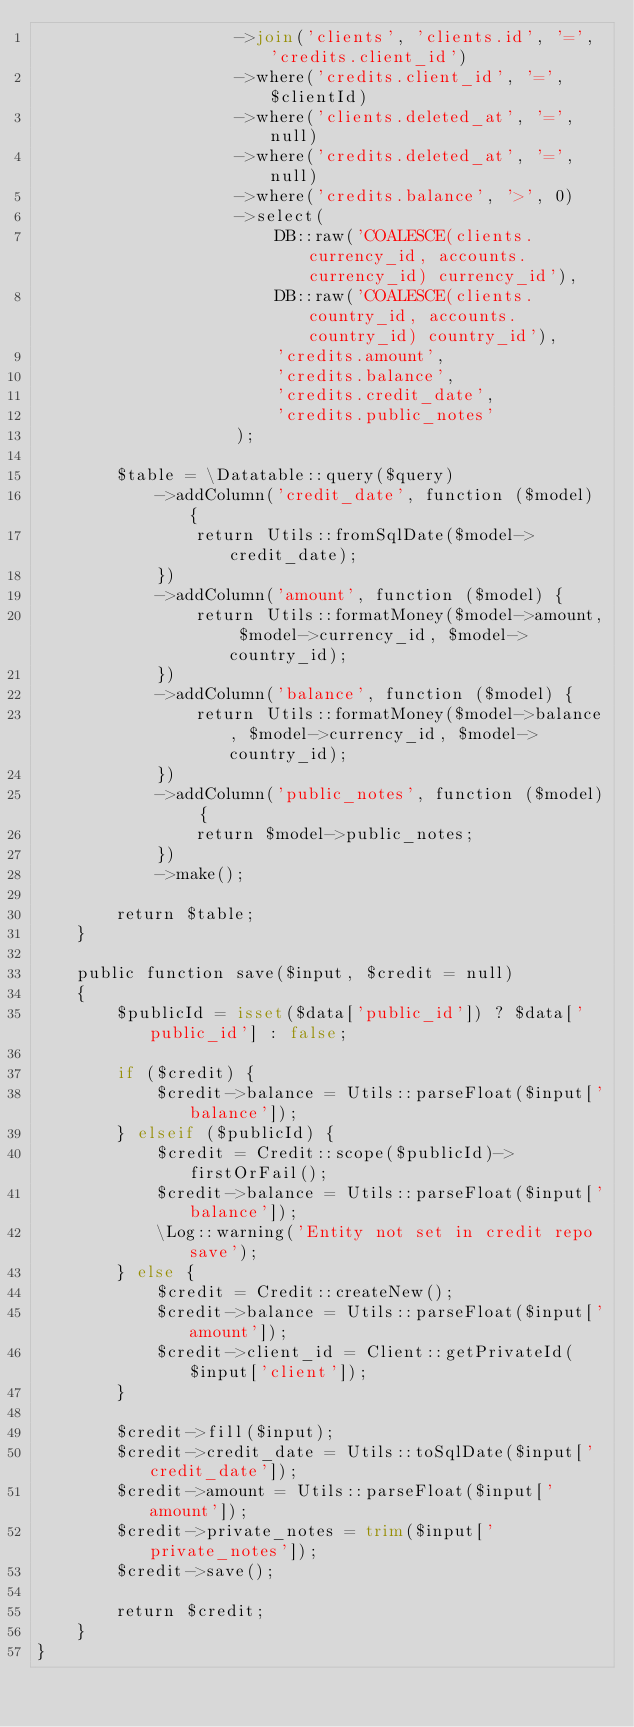Convert code to text. <code><loc_0><loc_0><loc_500><loc_500><_PHP_>                    ->join('clients', 'clients.id', '=', 'credits.client_id')
                    ->where('credits.client_id', '=', $clientId)
                    ->where('clients.deleted_at', '=', null)
                    ->where('credits.deleted_at', '=', null)
                    ->where('credits.balance', '>', 0)
                    ->select(
                        DB::raw('COALESCE(clients.currency_id, accounts.currency_id) currency_id'),
                        DB::raw('COALESCE(clients.country_id, accounts.country_id) country_id'),
                        'credits.amount',
                        'credits.balance',
                        'credits.credit_date',
                        'credits.public_notes'
                    );

        $table = \Datatable::query($query)
            ->addColumn('credit_date', function ($model) {
                return Utils::fromSqlDate($model->credit_date);
            })
            ->addColumn('amount', function ($model) {
                return Utils::formatMoney($model->amount, $model->currency_id, $model->country_id);
            })
            ->addColumn('balance', function ($model) {
                return Utils::formatMoney($model->balance, $model->currency_id, $model->country_id);
            })
            ->addColumn('public_notes', function ($model) {
                return $model->public_notes;
            })
            ->make();

        return $table;
    }

    public function save($input, $credit = null)
    {
        $publicId = isset($data['public_id']) ? $data['public_id'] : false;

        if ($credit) {
            $credit->balance = Utils::parseFloat($input['balance']);
        } elseif ($publicId) {
            $credit = Credit::scope($publicId)->firstOrFail();
            $credit->balance = Utils::parseFloat($input['balance']);
            \Log::warning('Entity not set in credit repo save');
        } else {
            $credit = Credit::createNew();
            $credit->balance = Utils::parseFloat($input['amount']);
            $credit->client_id = Client::getPrivateId($input['client']);
        }

        $credit->fill($input);
        $credit->credit_date = Utils::toSqlDate($input['credit_date']);
        $credit->amount = Utils::parseFloat($input['amount']);
        $credit->private_notes = trim($input['private_notes']);
        $credit->save();

        return $credit;
    }
}
</code> 